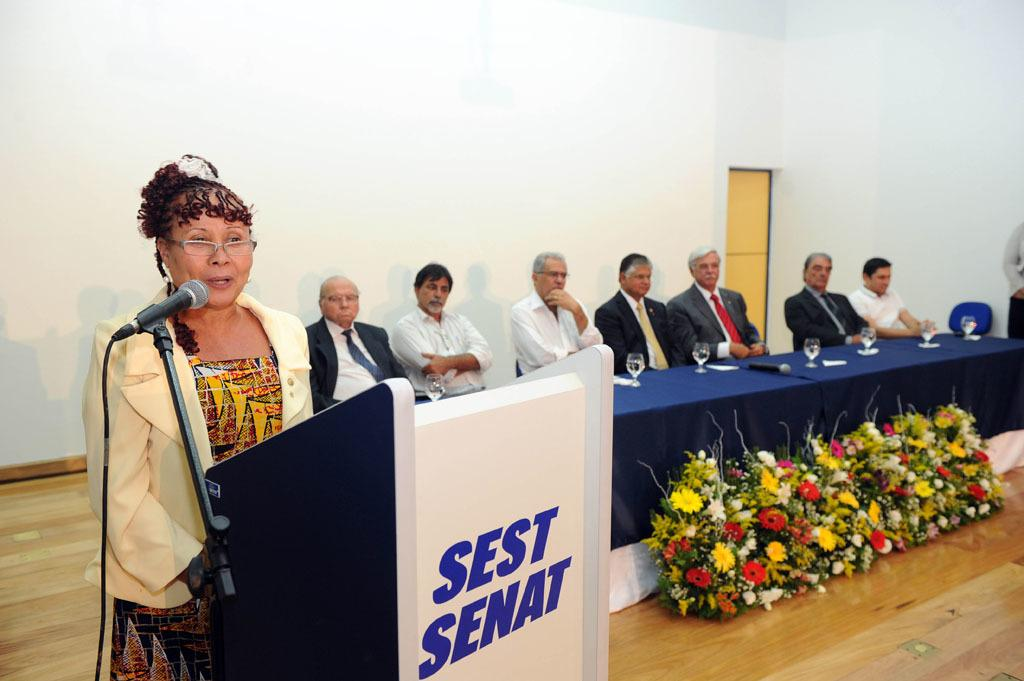<image>
Describe the image concisely. A woman speaking at a podium which has the words Sest Senat on it. 